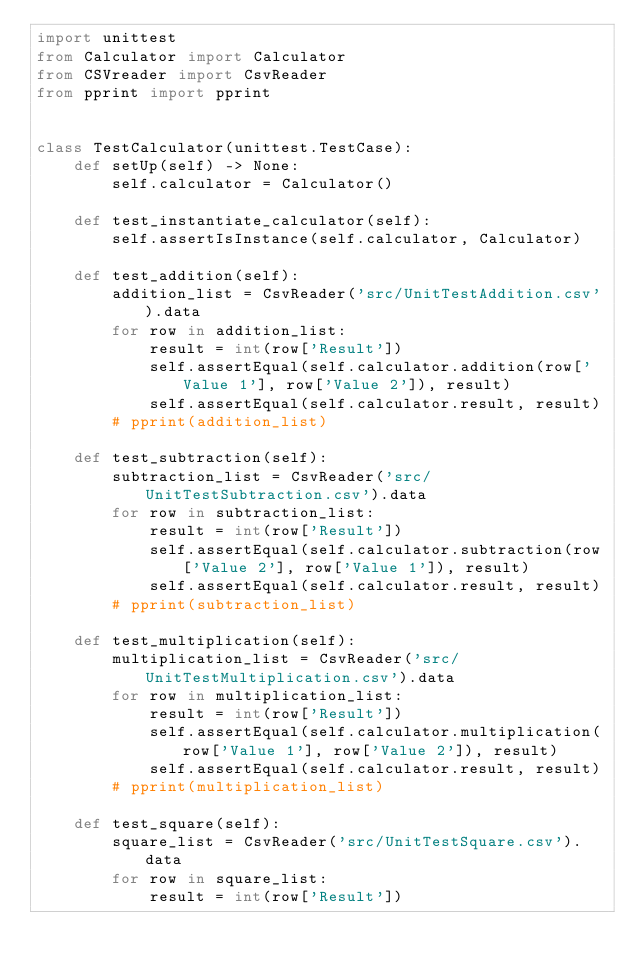Convert code to text. <code><loc_0><loc_0><loc_500><loc_500><_Python_>import unittest
from Calculator import Calculator
from CSVreader import CsvReader
from pprint import pprint


class TestCalculator(unittest.TestCase):
    def setUp(self) -> None:
        self.calculator = Calculator()

    def test_instantiate_calculator(self):
        self.assertIsInstance(self.calculator, Calculator)

    def test_addition(self):
        addition_list = CsvReader('src/UnitTestAddition.csv').data
        for row in addition_list:
            result = int(row['Result'])
            self.assertEqual(self.calculator.addition(row['Value 1'], row['Value 2']), result)
            self.assertEqual(self.calculator.result, result)
        # pprint(addition_list) 

    def test_subtraction(self):
        subtraction_list = CsvReader('src/UnitTestSubtraction.csv').data
        for row in subtraction_list:
            result = int(row['Result'])
            self.assertEqual(self.calculator.subtraction(row['Value 2'], row['Value 1']), result)
            self.assertEqual(self.calculator.result, result)
        # pprint(subtraction_list)

    def test_multiplication(self):
        multiplication_list = CsvReader('src/UnitTestMultiplication.csv').data
        for row in multiplication_list:
            result = int(row['Result'])
            self.assertEqual(self.calculator.multiplication(row['Value 1'], row['Value 2']), result)
            self.assertEqual(self.calculator.result, result)
        # pprint(multiplication_list)

    def test_square(self):
        square_list = CsvReader('src/UnitTestSquare.csv').data
        for row in square_list:
            result = int(row['Result'])</code> 